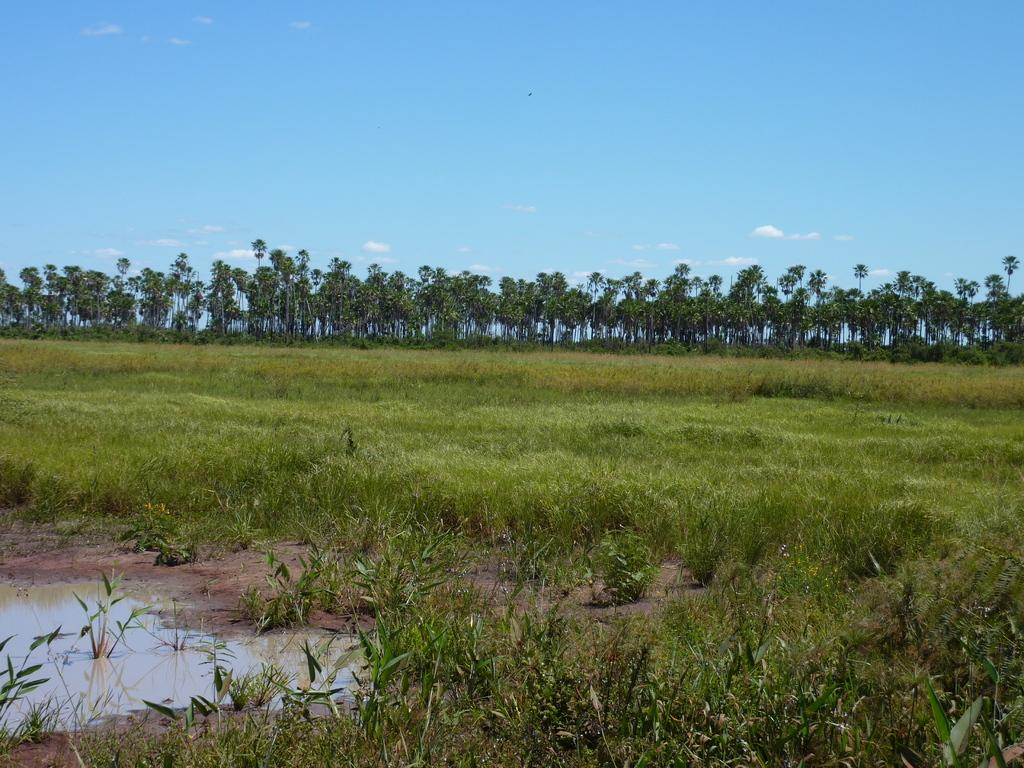What type of landscape is depicted in the image? There is a grassland in the image. What can be seen in the distance in the image? There are trees in the background of the image. What part of the natural environment is visible in the image? The sky is visible in the image. What is located on the bottom left of the image? There is a water surface on the bottom left of the image. Can you see a lawyer holding a receipt near the waste bin in the image? There is no lawyer, receipt, or waste bin present in the image. 